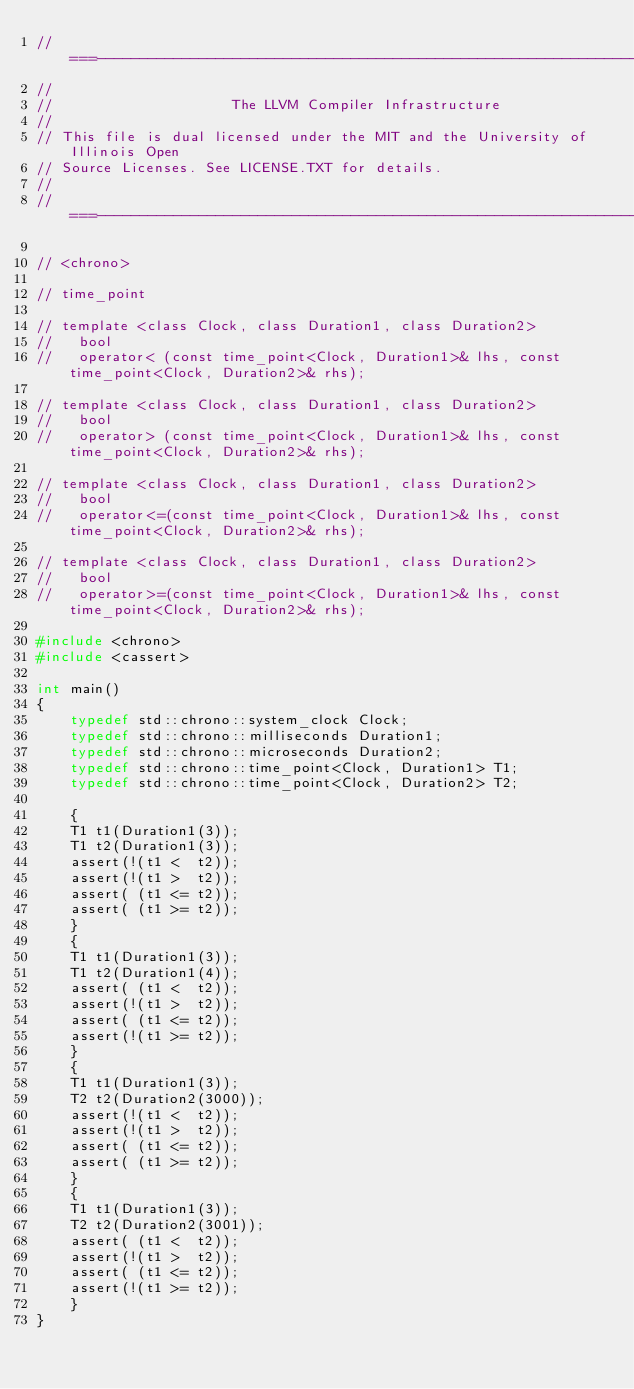<code> <loc_0><loc_0><loc_500><loc_500><_C++_>//===----------------------------------------------------------------------===//
//
//                     The LLVM Compiler Infrastructure
//
// This file is dual licensed under the MIT and the University of Illinois Open
// Source Licenses. See LICENSE.TXT for details.
//
//===----------------------------------------------------------------------===//

// <chrono>

// time_point

// template <class Clock, class Duration1, class Duration2>
//   bool
//   operator< (const time_point<Clock, Duration1>& lhs, const time_point<Clock, Duration2>& rhs);

// template <class Clock, class Duration1, class Duration2>
//   bool
//   operator> (const time_point<Clock, Duration1>& lhs, const time_point<Clock, Duration2>& rhs);

// template <class Clock, class Duration1, class Duration2>
//   bool
//   operator<=(const time_point<Clock, Duration1>& lhs, const time_point<Clock, Duration2>& rhs);

// template <class Clock, class Duration1, class Duration2>
//   bool
//   operator>=(const time_point<Clock, Duration1>& lhs, const time_point<Clock, Duration2>& rhs);

#include <chrono>
#include <cassert>

int main()
{
    typedef std::chrono::system_clock Clock;
    typedef std::chrono::milliseconds Duration1;
    typedef std::chrono::microseconds Duration2;
    typedef std::chrono::time_point<Clock, Duration1> T1;
    typedef std::chrono::time_point<Clock, Duration2> T2;

    {
    T1 t1(Duration1(3));
    T1 t2(Duration1(3));
    assert(!(t1 <  t2));
    assert(!(t1 >  t2));
    assert( (t1 <= t2));
    assert( (t1 >= t2));
    }
    {
    T1 t1(Duration1(3));
    T1 t2(Duration1(4));
    assert( (t1 <  t2));
    assert(!(t1 >  t2));
    assert( (t1 <= t2));
    assert(!(t1 >= t2));
    }
    {
    T1 t1(Duration1(3));
    T2 t2(Duration2(3000));
    assert(!(t1 <  t2));
    assert(!(t1 >  t2));
    assert( (t1 <= t2));
    assert( (t1 >= t2));
    }
    {
    T1 t1(Duration1(3));
    T2 t2(Duration2(3001));
    assert( (t1 <  t2));
    assert(!(t1 >  t2));
    assert( (t1 <= t2));
    assert(!(t1 >= t2));
    }
}
</code> 